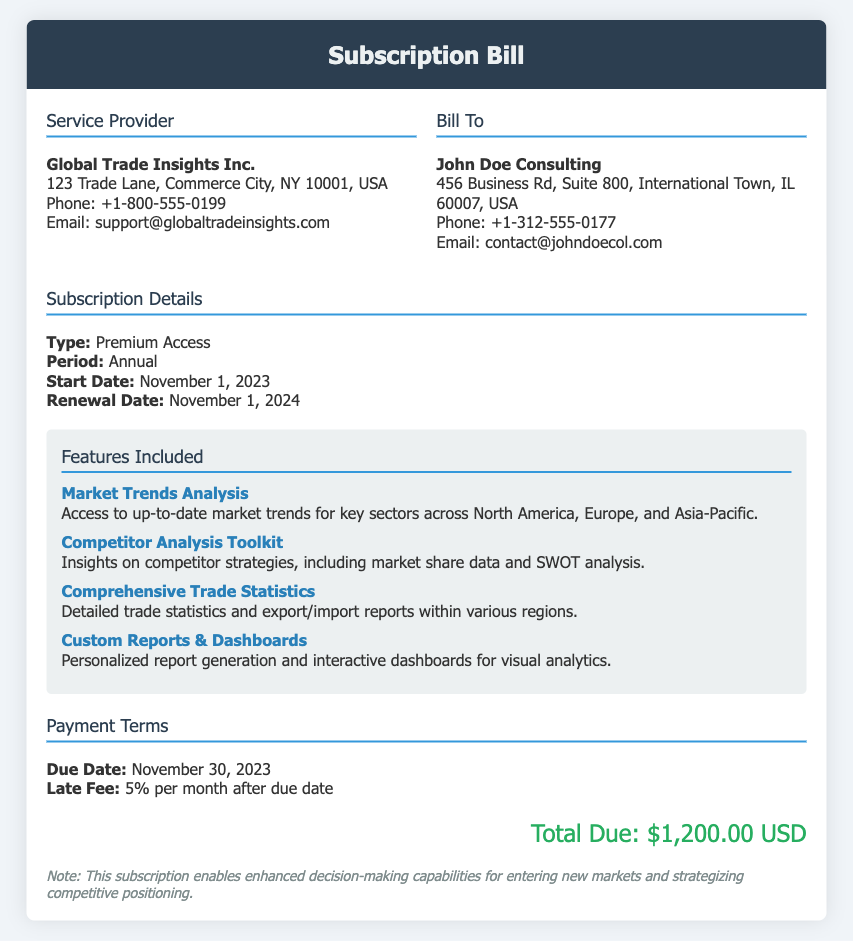What is the name of the service provider? The service provider is clearly stated in the document as Global Trade Insights Inc.
Answer: Global Trade Insights Inc What is the total due amount? The document specifies the total due amount in the financial section.
Answer: $1,200.00 USD When does the subscription period start? The subscription details include the start date of the service.
Answer: November 1, 2023 What feature provides insights on competitor strategies? One of the features listed discusses competitor strategies, identified in the document.
Answer: Competitor Analysis Toolkit What is the late fee rate after the due date? The payment terms section mentions the applicable late fee percentage.
Answer: 5% per month Who is the bill addressed to? The "Bill To" section identifies the recipient of the bill.
Answer: John Doe Consulting What date is the renewal scheduled for? The subscription details include the renewal date for the service.
Answer: November 1, 2024 Which region's trade statistics are included? The document states that comprehensive trade statistics cover multiple regions.
Answer: Various regions What is the contact email for support? Contact information is provided, including the support email address.
Answer: support@globaltradeinsights.com 